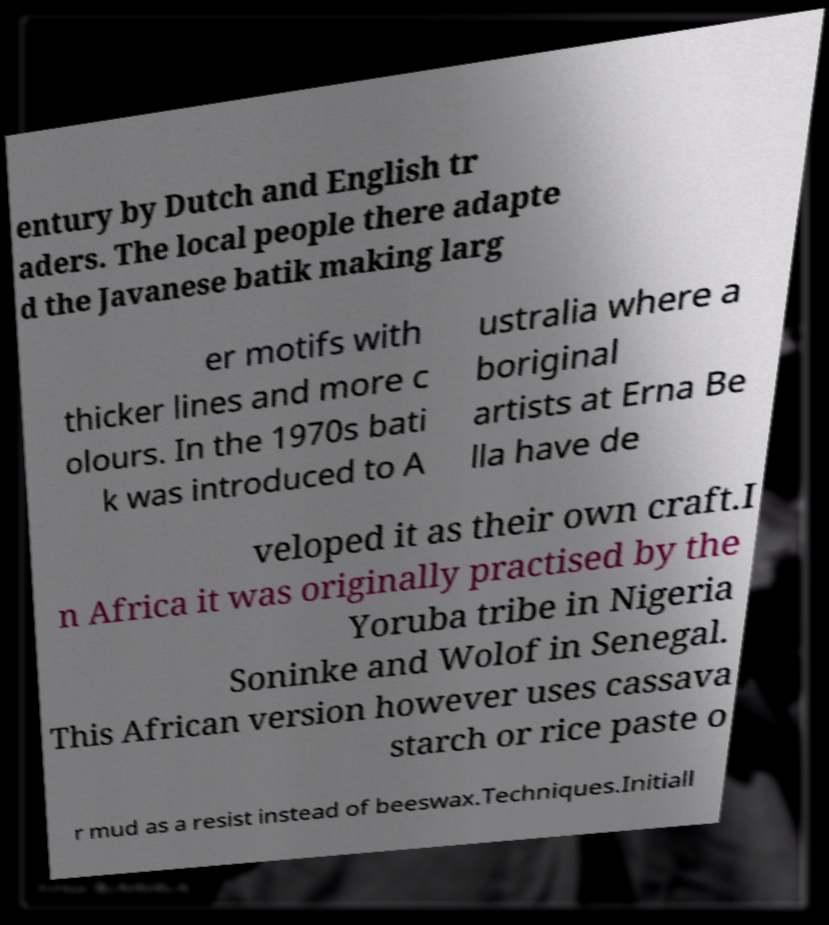Could you extract and type out the text from this image? entury by Dutch and English tr aders. The local people there adapte d the Javanese batik making larg er motifs with thicker lines and more c olours. In the 1970s bati k was introduced to A ustralia where a boriginal artists at Erna Be lla have de veloped it as their own craft.I n Africa it was originally practised by the Yoruba tribe in Nigeria Soninke and Wolof in Senegal. This African version however uses cassava starch or rice paste o r mud as a resist instead of beeswax.Techniques.Initiall 